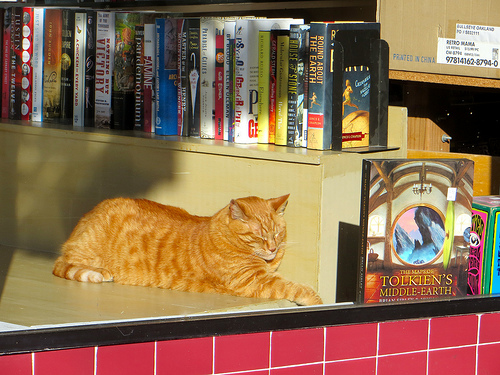<image>
Is the cat under the book? Yes. The cat is positioned underneath the book, with the book above it in the vertical space. 